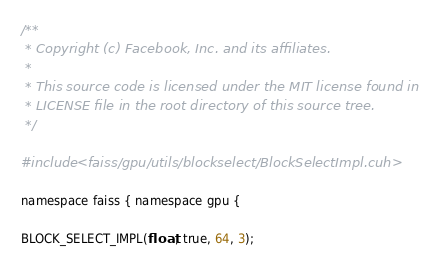Convert code to text. <code><loc_0><loc_0><loc_500><loc_500><_Cuda_>/**
 * Copyright (c) Facebook, Inc. and its affiliates.
 *
 * This source code is licensed under the MIT license found in the
 * LICENSE file in the root directory of this source tree.
 */

#include <faiss/gpu/utils/blockselect/BlockSelectImpl.cuh>

namespace faiss { namespace gpu {

BLOCK_SELECT_IMPL(float, true, 64, 3);</code> 